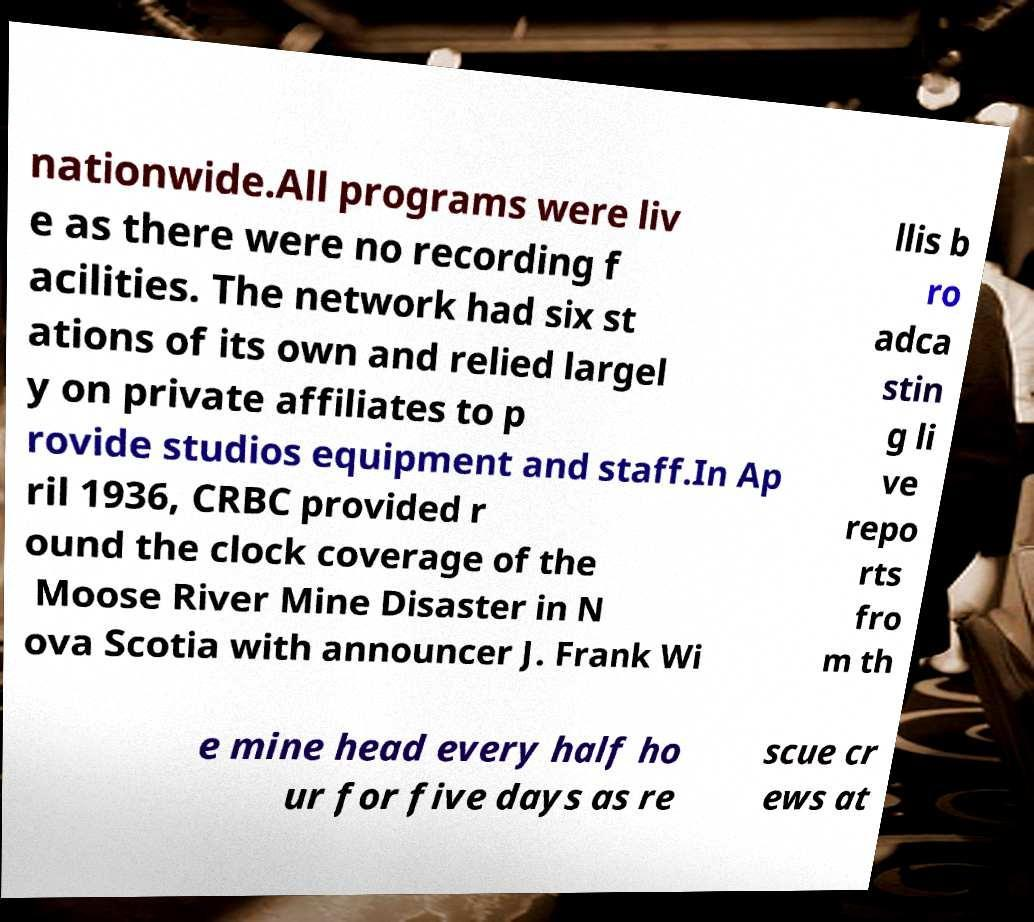There's text embedded in this image that I need extracted. Can you transcribe it verbatim? nationwide.All programs were liv e as there were no recording f acilities. The network had six st ations of its own and relied largel y on private affiliates to p rovide studios equipment and staff.In Ap ril 1936, CRBC provided r ound the clock coverage of the Moose River Mine Disaster in N ova Scotia with announcer J. Frank Wi llis b ro adca stin g li ve repo rts fro m th e mine head every half ho ur for five days as re scue cr ews at 